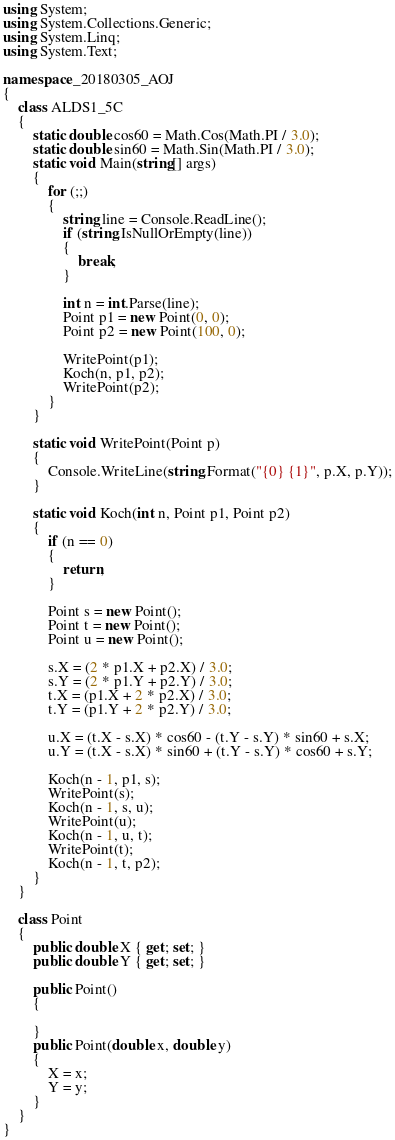<code> <loc_0><loc_0><loc_500><loc_500><_C#_>using System;
using System.Collections.Generic;
using System.Linq;
using System.Text;

namespace _20180305_AOJ
{
    class ALDS1_5C
    {
        static double cos60 = Math.Cos(Math.PI / 3.0);
        static double sin60 = Math.Sin(Math.PI / 3.0);
        static void Main(string[] args)
        {
            for (;;)
            {
                string line = Console.ReadLine();
                if (string.IsNullOrEmpty(line))
                {
                    break;
                }

                int n = int.Parse(line);
                Point p1 = new Point(0, 0);
                Point p2 = new Point(100, 0);

                WritePoint(p1);
                Koch(n, p1, p2);
                WritePoint(p2);
            }
        }

        static void WritePoint(Point p)
        {
            Console.WriteLine(string.Format("{0} {1}", p.X, p.Y));
        }

        static void Koch(int n, Point p1, Point p2)
        {
            if (n == 0)
            {
                return;
            }

            Point s = new Point();
            Point t = new Point();
            Point u = new Point();

            s.X = (2 * p1.X + p2.X) / 3.0;
            s.Y = (2 * p1.Y + p2.Y) / 3.0;
            t.X = (p1.X + 2 * p2.X) / 3.0;
            t.Y = (p1.Y + 2 * p2.Y) / 3.0;

            u.X = (t.X - s.X) * cos60 - (t.Y - s.Y) * sin60 + s.X;
            u.Y = (t.X - s.X) * sin60 + (t.Y - s.Y) * cos60 + s.Y;

            Koch(n - 1, p1, s);
            WritePoint(s);
            Koch(n - 1, s, u);
            WritePoint(u);
            Koch(n - 1, u, t);
            WritePoint(t);
            Koch(n - 1, t, p2);
        }
    }

    class Point
    {
        public double X { get; set; }
        public double Y { get; set; }

        public Point()
        {

        }
        public Point(double x, double y)
        {
            X = x;
            Y = y;
        }
    }
}

</code> 